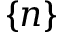<formula> <loc_0><loc_0><loc_500><loc_500>\{ \boldsymbol n \}</formula> 